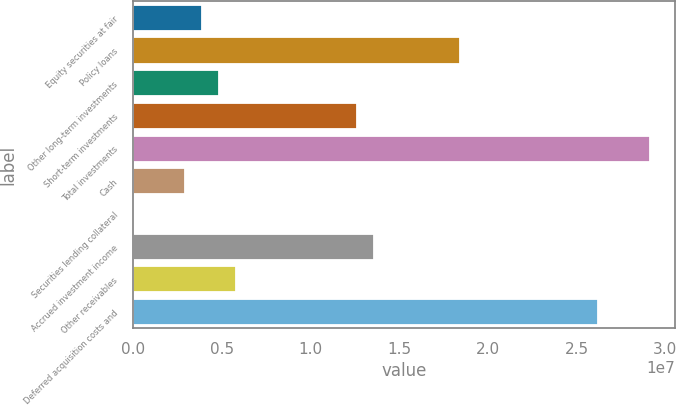Convert chart to OTSL. <chart><loc_0><loc_0><loc_500><loc_500><bar_chart><fcel>Equity securities at fair<fcel>Policy loans<fcel>Other long-term investments<fcel>Short-term investments<fcel>Total investments<fcel>Cash<fcel>Securities lending collateral<fcel>Accrued investment income<fcel>Other receivables<fcel>Deferred acquisition costs and<nl><fcel>3.88131e+06<fcel>1.84362e+07<fcel>4.85164e+06<fcel>1.26143e+07<fcel>2.91098e+07<fcel>2.91098e+06<fcel>0.41<fcel>1.35846e+07<fcel>5.82196e+06<fcel>2.61988e+07<nl></chart> 